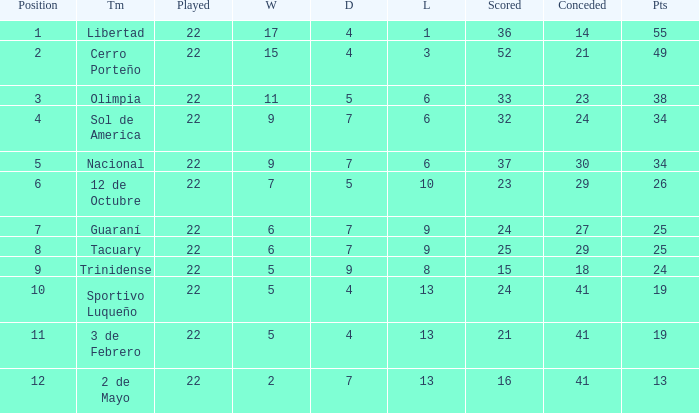What is the fewest wins that has fewer than 23 goals scored, team of 2 de Mayo, and fewer than 7 draws? None. Could you help me parse every detail presented in this table? {'header': ['Position', 'Tm', 'Played', 'W', 'D', 'L', 'Scored', 'Conceded', 'Pts'], 'rows': [['1', 'Libertad', '22', '17', '4', '1', '36', '14', '55'], ['2', 'Cerro Porteño', '22', '15', '4', '3', '52', '21', '49'], ['3', 'Olimpia', '22', '11', '5', '6', '33', '23', '38'], ['4', 'Sol de America', '22', '9', '7', '6', '32', '24', '34'], ['5', 'Nacional', '22', '9', '7', '6', '37', '30', '34'], ['6', '12 de Octubre', '22', '7', '5', '10', '23', '29', '26'], ['7', 'Guaraní', '22', '6', '7', '9', '24', '27', '25'], ['8', 'Tacuary', '22', '6', '7', '9', '25', '29', '25'], ['9', 'Trinidense', '22', '5', '9', '8', '15', '18', '24'], ['10', 'Sportivo Luqueño', '22', '5', '4', '13', '24', '41', '19'], ['11', '3 de Febrero', '22', '5', '4', '13', '21', '41', '19'], ['12', '2 de Mayo', '22', '2', '7', '13', '16', '41', '13']]} 